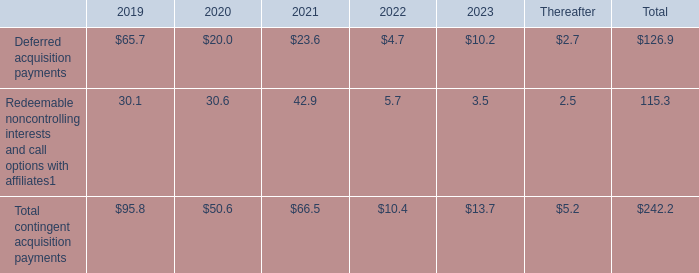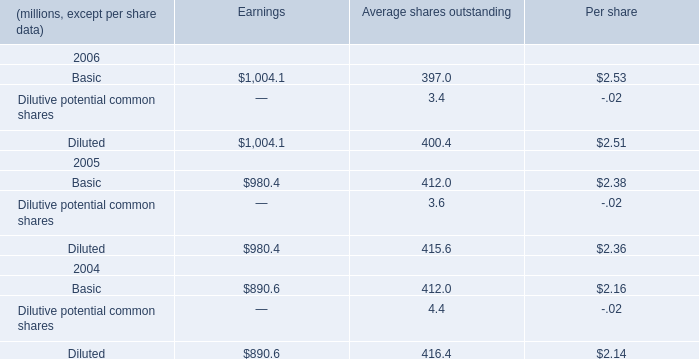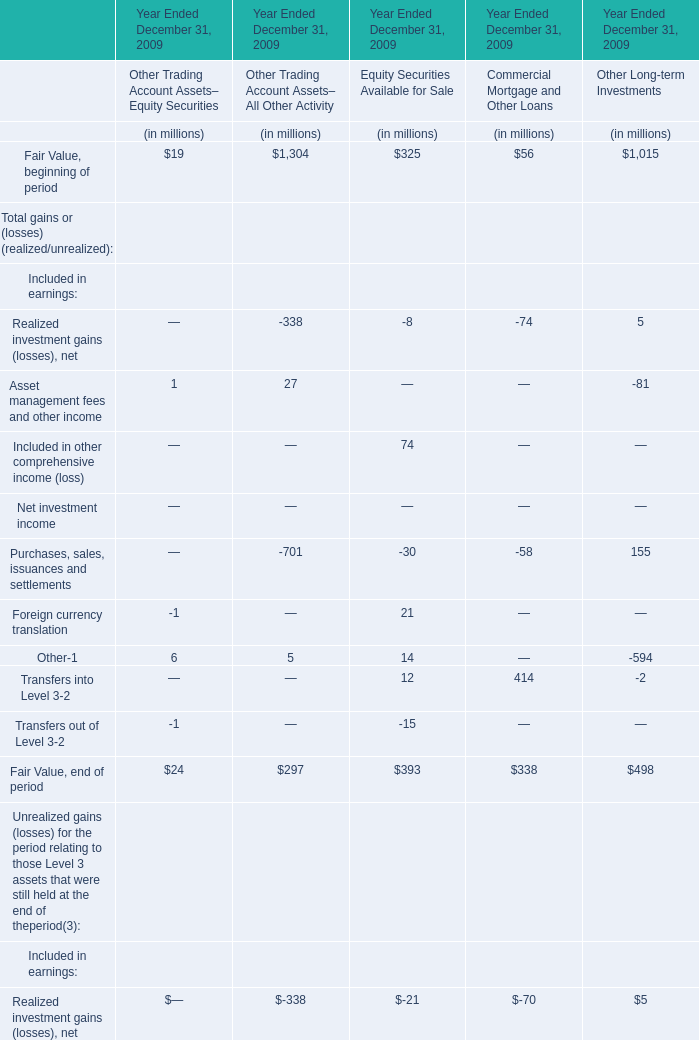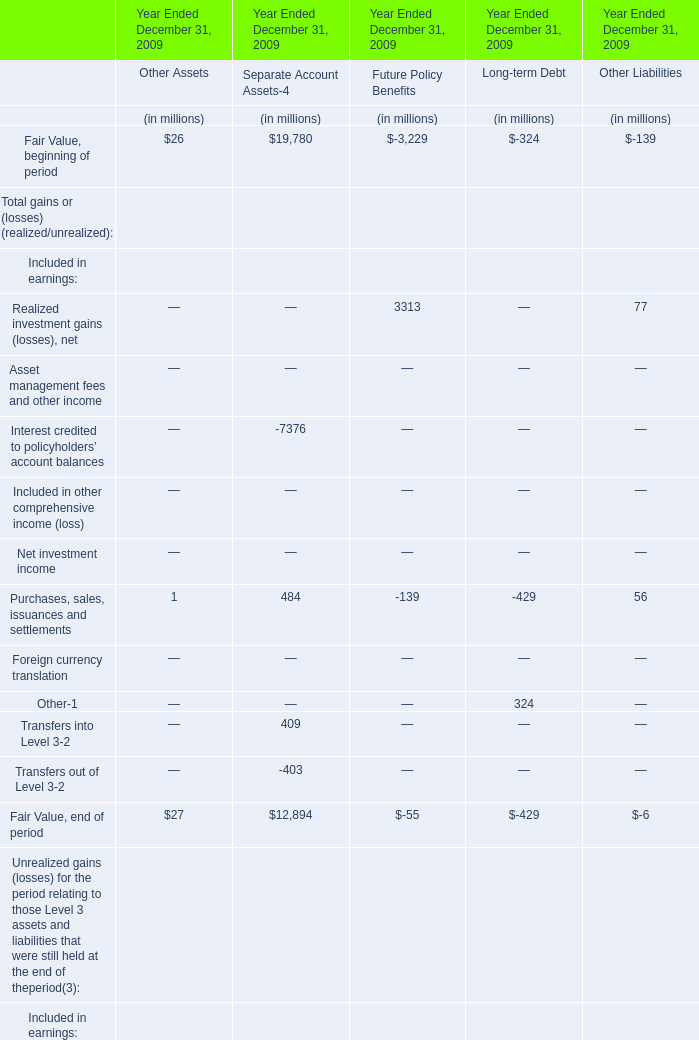What was the Fair Value, end of period for Separate Account Assets for Year Ended December 31, 2009? (in million) 
Answer: 12894. 